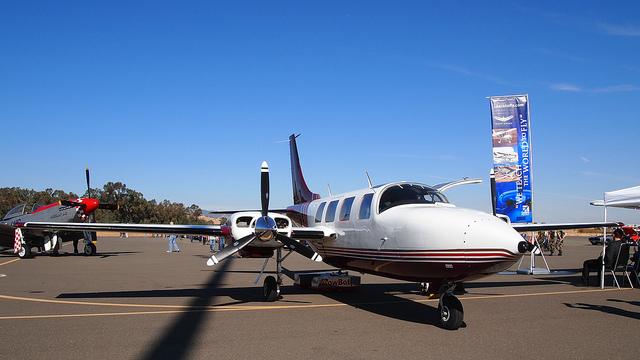What color is the propeller?
Short answer required. Black. Is there a kid checking under the plane?
Keep it brief. No. How many people can fit inside the plane?
Quick response, please. 10. How many pilots are in the cockpit?
Keep it brief. 0. Is this a large plane?
Write a very short answer. No. Does this plane have propellers?
Short answer required. Yes. What type of plane is this?
Give a very brief answer. Propeller plane. Is there a catering truck next to the plane?
Give a very brief answer. No. Is this a color picture?
Concise answer only. Yes. Was the photographer of this photo outside?
Answer briefly. Yes. What colors are on the plane?
Give a very brief answer. Red and blue. Is the plane in the air?
Answer briefly. No. 